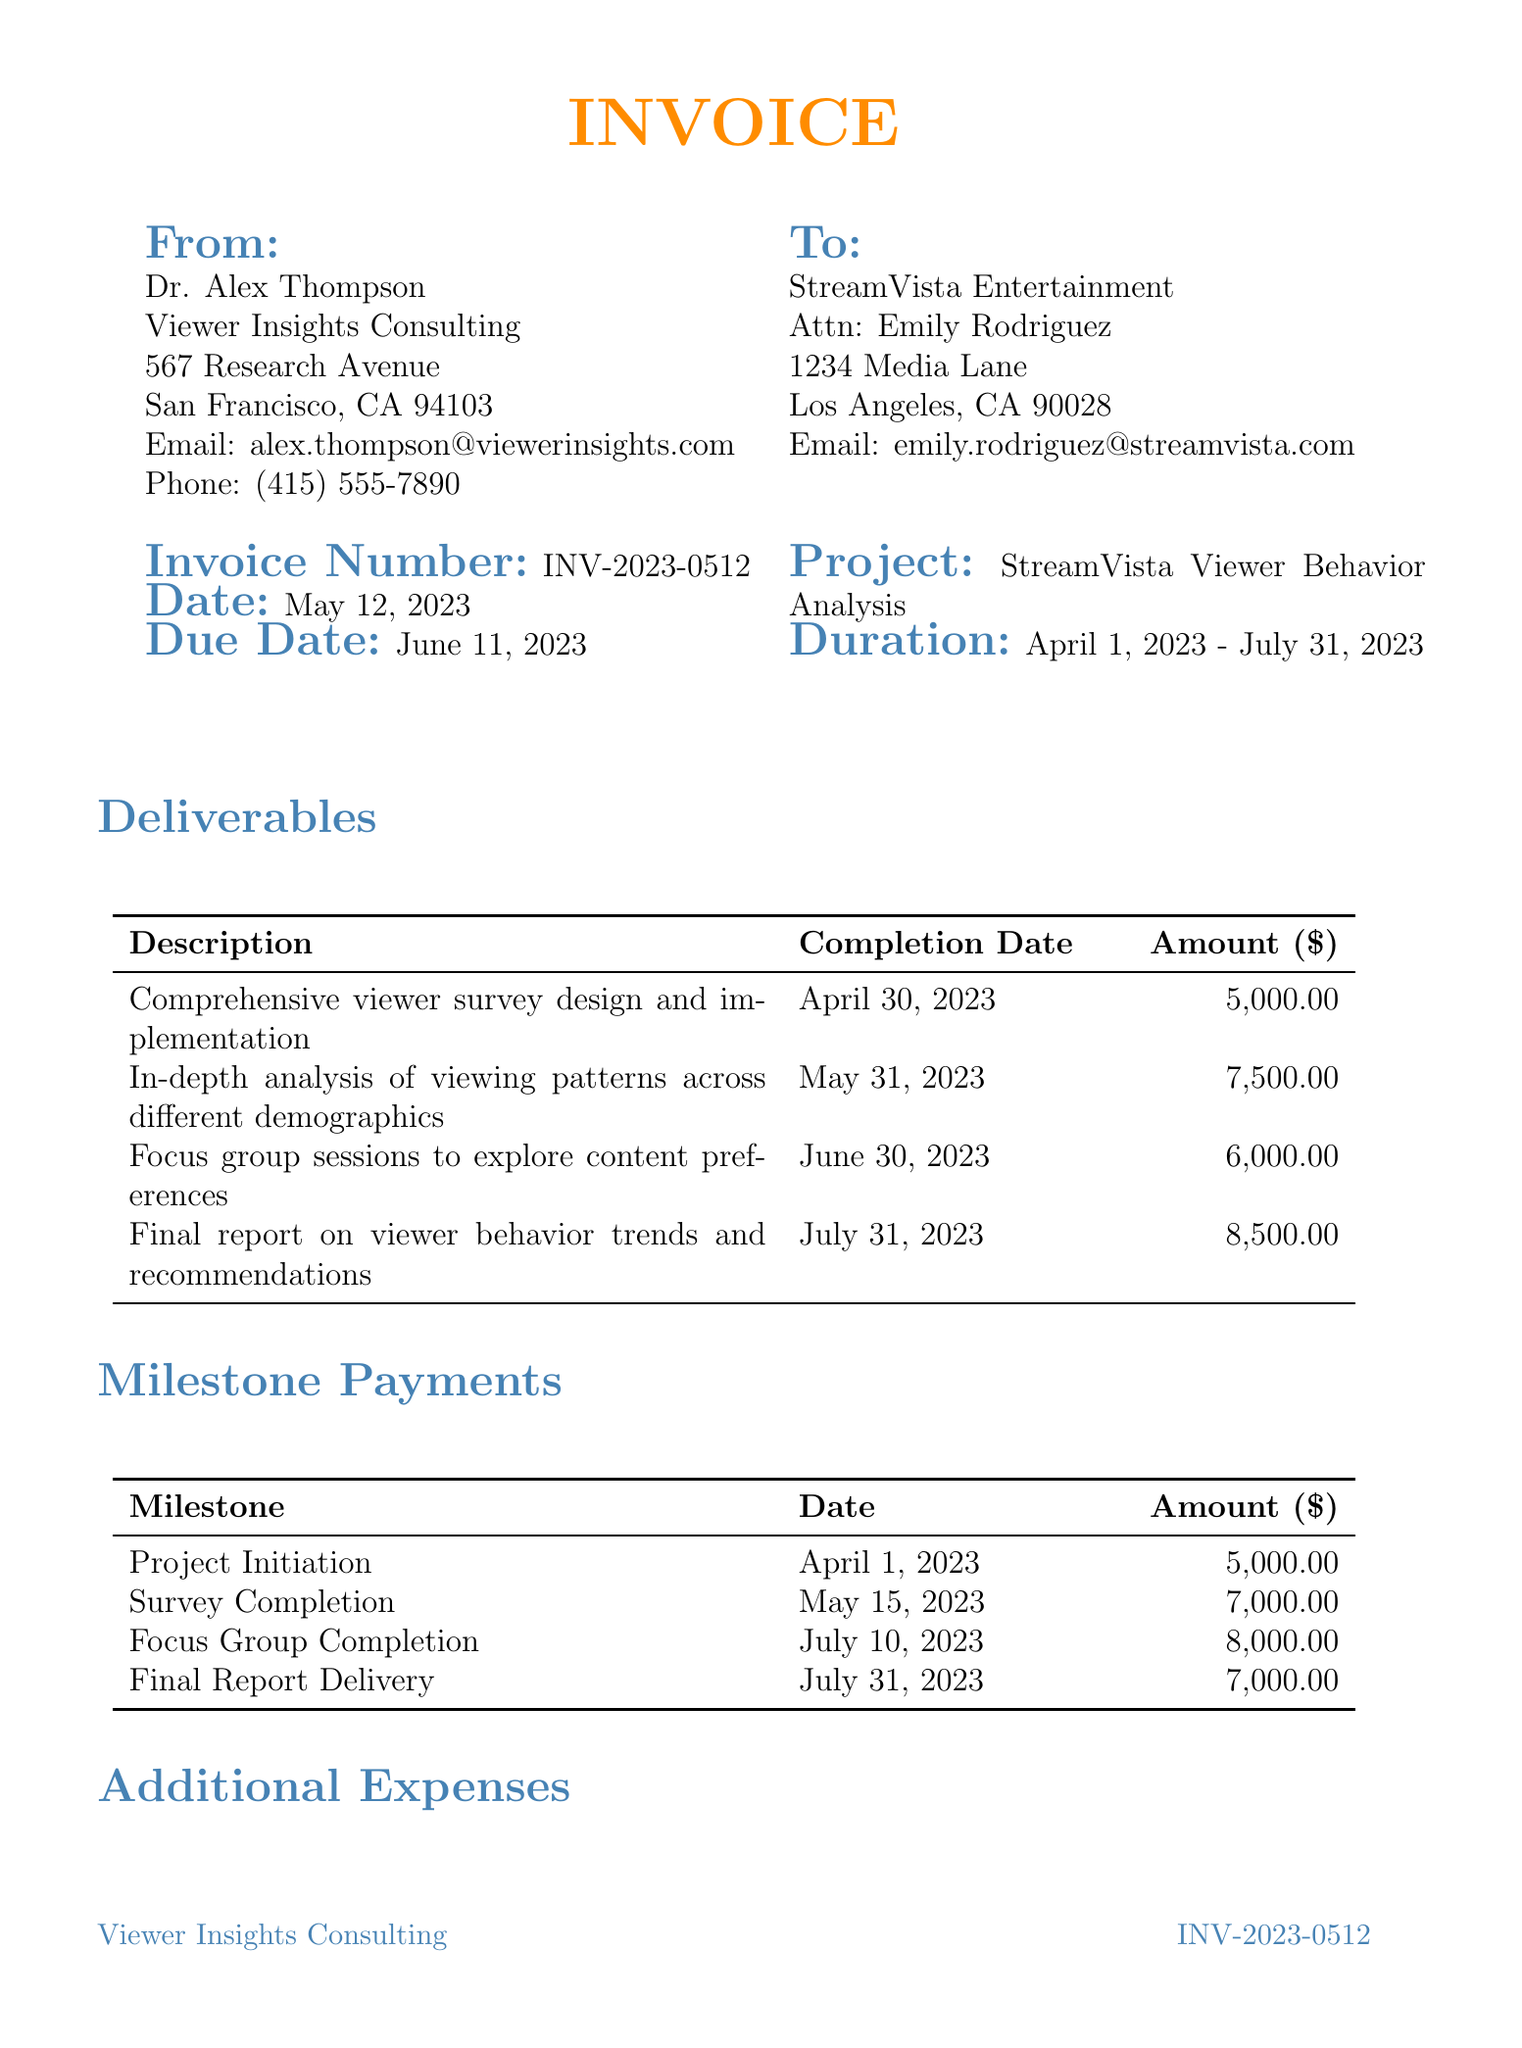What is the invoice number? The invoice number can be found in the invoice details section of the document.
Answer: INV-2023-0512 What is the due date for this invoice? The due date is indicated in the invoice details section and refers to the date by which payment must be made.
Answer: June 11, 2023 Who is the contact person for the client? The contact person for the client is specified under client information in the document.
Answer: Emily Rodriguez What is the amount due for the focus group sessions? The amount due for the focus group sessions is listed under deliverables, showing the cost for that specific service.
Answer: 6000 When is the final report due? The completion date for the final report is specified under deliverables, indicating when the report must be finished.
Answer: July 31, 2023 What is the total amount due on the invoice? The total amount due is indicated at the bottom of the invoice, summarizing all fees and expenses.
Answer: 37300 How many milestone payments are listed in the invoice? The number of milestone payments can be counted in the milestone payment section of the document.
Answer: 4 What method of payment is specified? The method of payment is outlined in the payment terms section of the invoice.
Answer: Bank transfer What project is this invoice related to? The project for which this invoice is issued can be found in the project details section.
Answer: StreamVista Viewer Behavior Analysis 